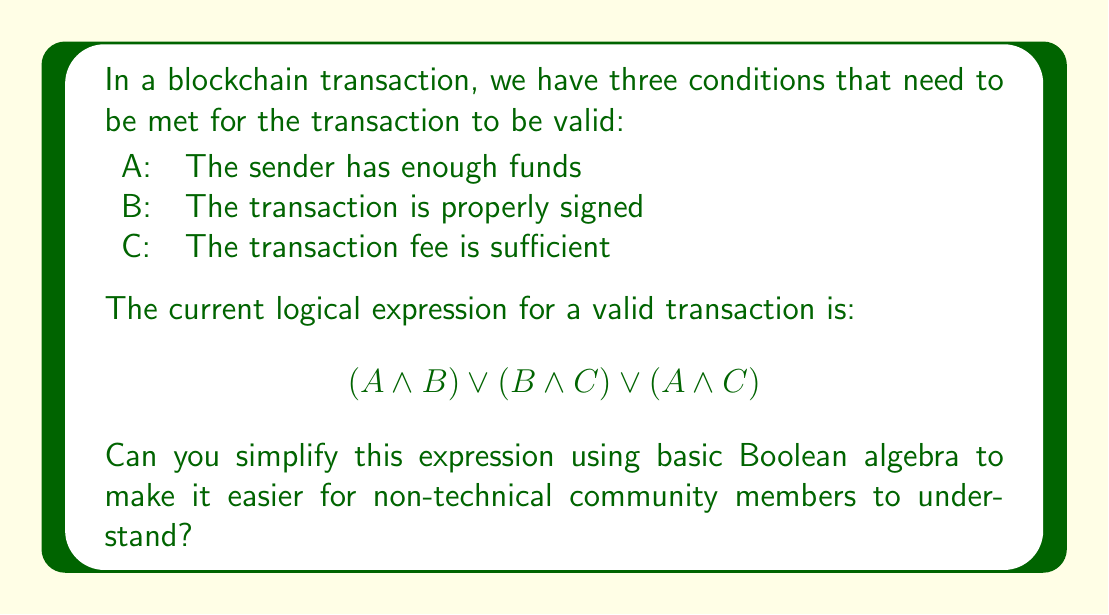Can you answer this question? Let's simplify this expression step by step:

1) First, we can use the distributive property of Boolean algebra. This property states that $A \land (B \lor C) = (A \land B) \lor (A \land C)$. We can apply this in reverse:

   $$(A \land B) \lor (B \land C) \lor (A \land C)$$
   $$= B \land (A \lor C) \lor (A \land C)$$

2) Now, we can use the absorption law, which states that $A \lor (A \land B) = A$. In our case:

   $$B \land (A \lor C) \lor (A \land C)$$
   $$= B \land (A \lor C) \lor C \land (A \lor C)$$
   $$= (B \lor C) \land (A \lor C)$$

3) This is our simplified expression. It means that for a transaction to be valid, either B or C must be true (the transaction is properly signed or the fee is sufficient), AND either A or C must be true (the sender has enough funds or the fee is sufficient).

This simplification reduces the original expression from three terms to two, making it easier to understand and evaluate.
Answer: $$(B \lor C) \land (A \lor C)$$ 